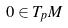Convert formula to latex. <formula><loc_0><loc_0><loc_500><loc_500>0 \in T _ { p } M</formula> 